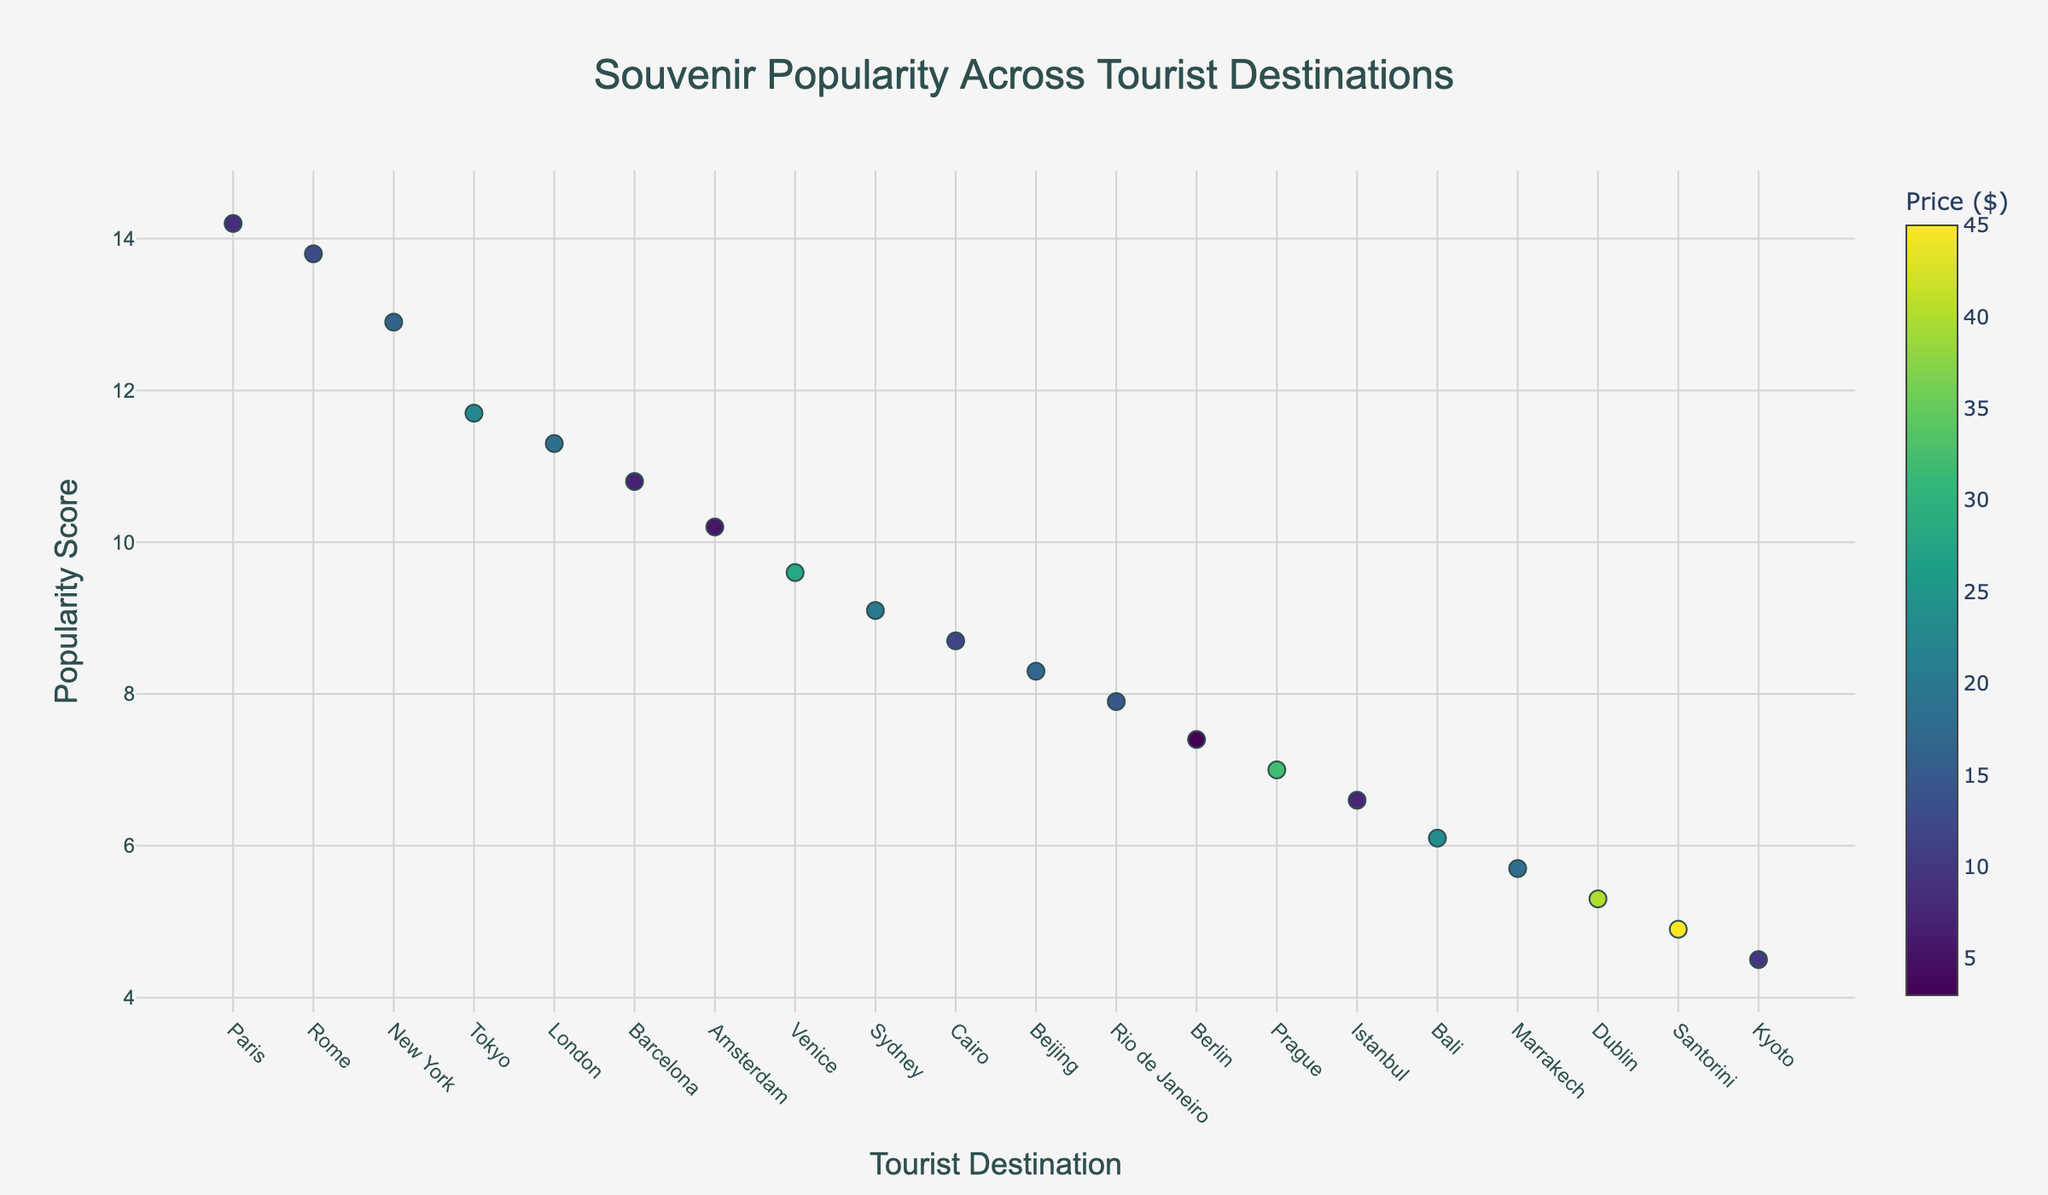How many tourist destinations are represented in the plot? The X-axis displays the names of the tourist destinations, and counting them will give us the number.
Answer: 19 Which tourist destination has the highest popularity score? The Y-axis shows the popularity scores, and the highest point on this axis corresponds to the tourist destination that has the highest popularity score.
Answer: Paris Which souvenir has the lowest price, and what is its price? The color bar indicates the price, and the lightest marker represents the lowest price among all souvenirs. By hovering over the lightest marker, we get the item name and its price.
Answer: Brandenburg Gate Postcard, $2.99 Compare the popularity scores of souvenirs from New York and Tokyo. Which one is more popular? Locate the points for New York and Tokyo on the X-axis and compare their Y-axis values (popularity scores). New York has a higher Y-value compared to Tokyo.
Answer: New York What's the average price of the souvenirs from the top 3 most popular tourist destinations? Identify the top 3 points with the highest popularity scores, note their prices, and calculate their average. Prices: $8.50, $12.75, $15.99. The average price is (8.50 + 12.75 + 15.99) / 3 = 37.24 / 3.
Answer: $12.41 Which souvenir has a higher popularity score: Boomerang from Sydney or Murano Glass Pendant from Venice? Locate the Boomerang and Murano Glass Pendant points and compare their Y-axis values. The Boomerang from Sydney has a higher popularity score than the Murano Glass Pendant from Venice.
Answer: Boomerang from Sydney Are there any souvenirs priced above $30? If yes, name one. The color bar on the right shows the price, with the darkest markers representing the highest prices. By hovering over the darkest markers, we find their names and prices.
Answer: Astronomical Clock Replica What is the typical price range of the souvenirs with a popularity score above 9.0? Identify all points with popularity scores above 9.0 and observe their corresponding colors to determine the price range by checking against the color bar.
Answer: $6.99 to $22.50 How does the popularity score of the Claddagh Ring from Dublin compare to that of the Folding Fan from Kyoto? Locate both points and compare their Y-axis values. The Claddagh Ring has a higher popularity score compared to the Folding Fan from Kyoto.
Answer: Claddagh Ring 